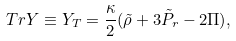<formula> <loc_0><loc_0><loc_500><loc_500>T r Y \equiv Y _ { T } = \frac { \kappa } { 2 } ( \tilde { \rho } + 3 \tilde { P } _ { r } - 2 \Pi ) ,</formula> 